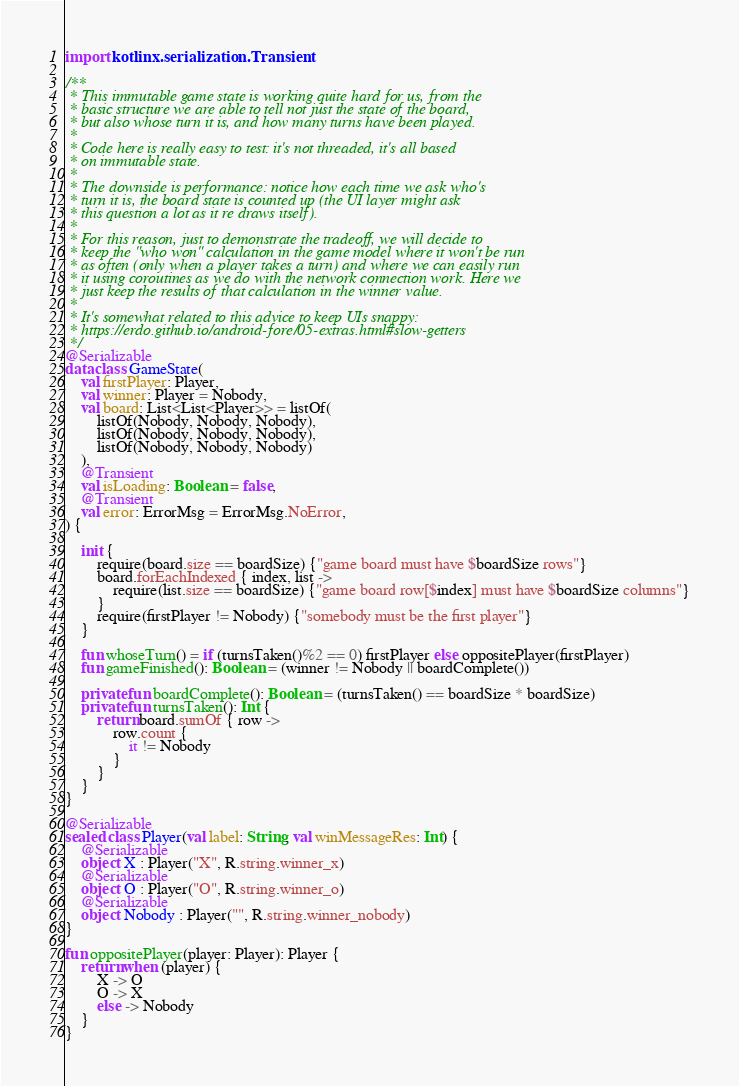<code> <loc_0><loc_0><loc_500><loc_500><_Kotlin_>import kotlinx.serialization.Transient

/**
 * This immutable game state is working quite hard for us, from the
 * basic structure we are able to tell not just the state of the board,
 * but also whose turn it is, and how many turns have been played.
 *
 * Code here is really easy to test: it's not threaded, it's all based
 * on immutable state.
 *
 * The downside is performance: notice how each time we ask who's
 * turn it is, the board state is counted up (the UI layer might ask
 * this question a lot as it re draws itself).
 *
 * For this reason, just to demonstrate the tradeoff, we will decide to
 * keep the "who won" calculation in the game model where it won't be run
 * as often (only when a player takes a turn) and where we can easily run
 * it using coroutines as we do with the network connection work. Here we
 * just keep the results of that calculation in the winner value.
 *
 * It's somewhat related to this advice to keep UIs snappy:
 * https://erdo.github.io/android-fore/05-extras.html#slow-getters
 */
@Serializable
data class GameState(
    val firstPlayer: Player,
    val winner: Player = Nobody,
    val board: List<List<Player>> = listOf(
        listOf(Nobody, Nobody, Nobody),
        listOf(Nobody, Nobody, Nobody),
        listOf(Nobody, Nobody, Nobody)
    ),
    @Transient
    val isLoading: Boolean = false,
    @Transient
    val error: ErrorMsg = ErrorMsg.NoError,
) {

    init {
        require(board.size == boardSize) {"game board must have $boardSize rows"}
        board.forEachIndexed { index, list ->
            require(list.size == boardSize) {"game board row[$index] must have $boardSize columns"}
        }
        require(firstPlayer != Nobody) {"somebody must be the first player"}
    }

    fun whoseTurn() = if (turnsTaken()%2 == 0) firstPlayer else oppositePlayer(firstPlayer)
    fun gameFinished(): Boolean = (winner != Nobody || boardComplete())

    private fun boardComplete(): Boolean = (turnsTaken() == boardSize * boardSize)
    private fun turnsTaken(): Int {
        return board.sumOf { row ->
            row.count {
                it != Nobody
            }
        }
    }
}

@Serializable
sealed class Player(val label: String, val winMessageRes: Int) {
    @Serializable
    object X : Player("X", R.string.winner_x)
    @Serializable
    object O : Player("O", R.string.winner_o)
    @Serializable
    object Nobody : Player("", R.string.winner_nobody)
}

fun oppositePlayer(player: Player): Player {
    return when (player) {
        X -> O
        O -> X
        else -> Nobody
    }
}
</code> 